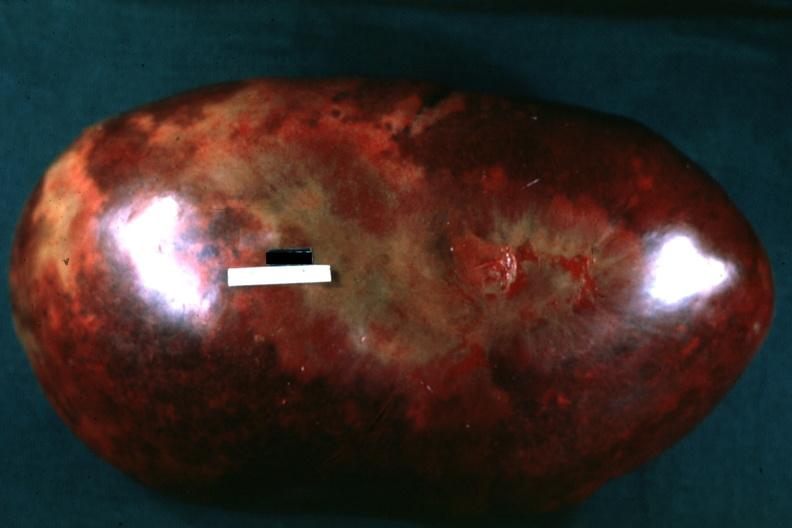what is present?
Answer the question using a single word or phrase. Chronic myelogenous leukemia 